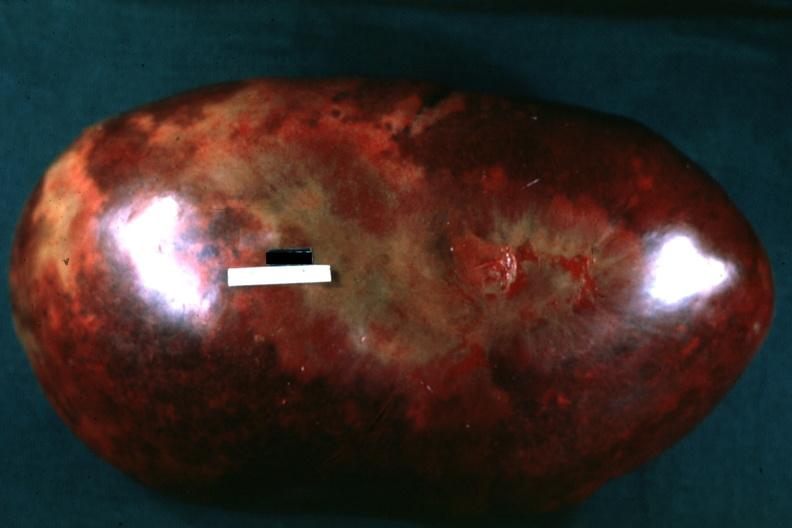what is present?
Answer the question using a single word or phrase. Chronic myelogenous leukemia 